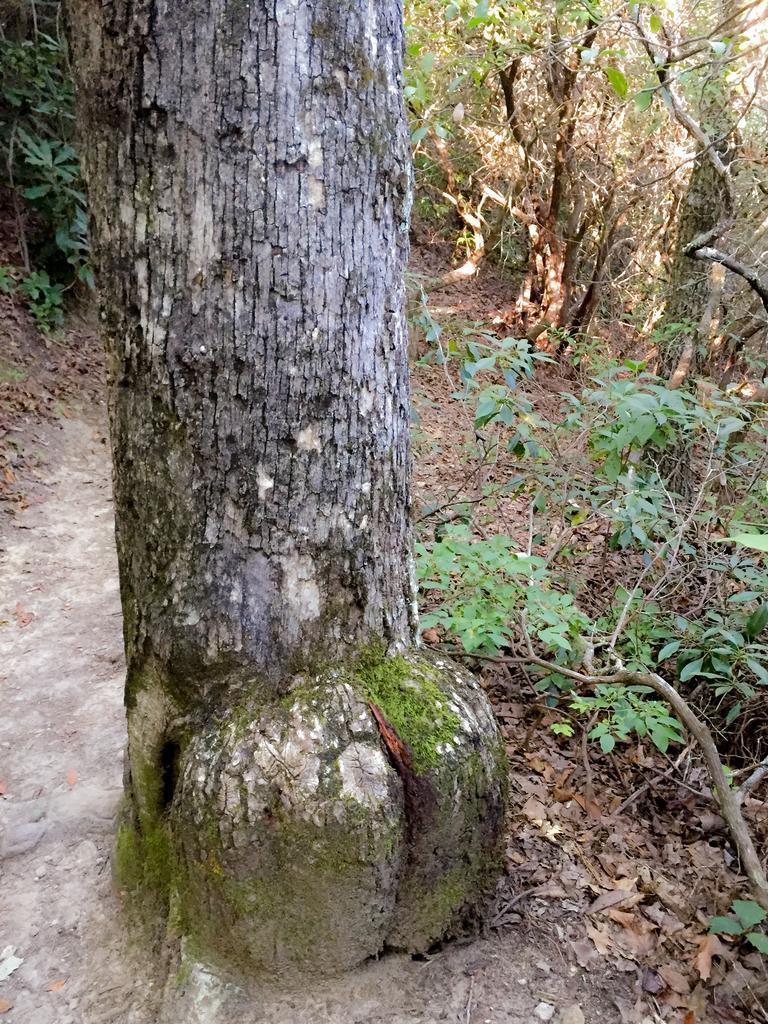How would you summarize this image in a sentence or two? In this image we can see a truncated tree, plants and leaves on the ground. 